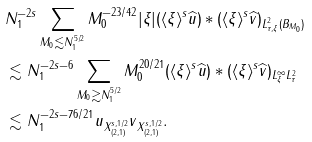<formula> <loc_0><loc_0><loc_500><loc_500>& N _ { 1 } ^ { - 2 s } \sum _ { M _ { 0 } \lesssim N _ { 1 } ^ { 5 / 2 } } M _ { 0 } ^ { - 2 3 / 4 2 } \| | \xi | ( \langle \xi \rangle ^ { s } \widehat { u } ) * ( \langle \xi \rangle ^ { s } \widehat { v } ) \| _ { L _ { \tau , \xi } ^ { 2 } ( B _ { M _ { 0 } } ) } \\ & \lesssim N _ { 1 } ^ { - 2 s - 6 } \sum _ { M _ { 0 } \gtrsim N _ { 1 } ^ { 5 / 2 } } M _ { 0 } ^ { 2 0 / 2 1 } \| ( \langle \xi \rangle ^ { s } \widehat { u } ) * ( \langle \xi \rangle ^ { s } \widehat { v } ) \| _ { L _ { \xi } ^ { \infty } L _ { \tau } ^ { 2 } } \\ & \lesssim N _ { 1 } ^ { - 2 s - 7 6 / 2 1 } \| u \| _ { X _ { ( 2 , 1 ) } ^ { s , 1 / 2 } } \| v \| _ { X _ { ( 2 , 1 ) } ^ { s , 1 / 2 } } .</formula> 